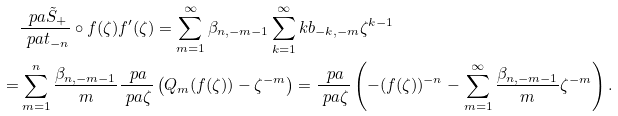<formula> <loc_0><loc_0><loc_500><loc_500>& \frac { \ p a \tilde { S } _ { + } } { \ p a t _ { - n } } \circ f ( \zeta ) f ^ { \prime } ( \zeta ) = \sum _ { m = 1 } ^ { \infty } \beta _ { n , - m - 1 } \sum _ { k = 1 } ^ { \infty } k b _ { - k , - m } \zeta ^ { k - 1 } \\ = & \sum _ { m = 1 } ^ { n } \frac { \beta _ { n , - m - 1 } } { m } \frac { \ p a } { \ p a \zeta } \left ( Q _ { m } ( f ( \zeta ) ) - \zeta ^ { - m } \right ) = \frac { \ p a } { \ p a \zeta } \left ( - ( f ( \zeta ) ) ^ { - n } - \sum _ { m = 1 } ^ { \infty } \frac { \beta _ { n , - m - 1 } } { m } \zeta ^ { - m } \right ) .</formula> 